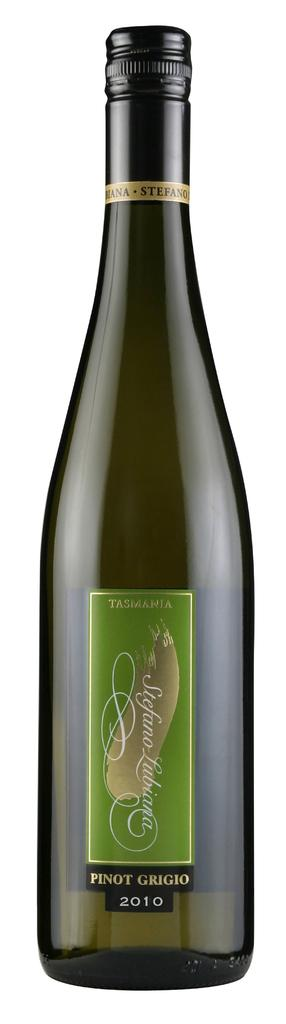<image>
Write a terse but informative summary of the picture. a bottle of Pinot Grigio on a white back ground 